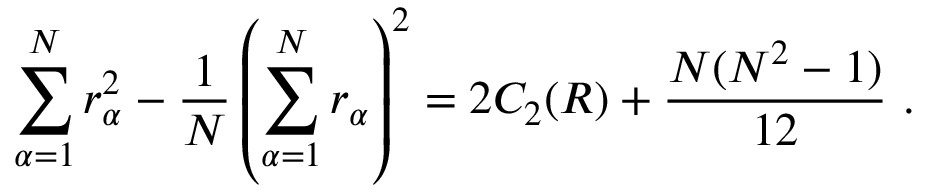Convert formula to latex. <formula><loc_0><loc_0><loc_500><loc_500>\sum _ { \alpha = 1 } ^ { N } r _ { \alpha } ^ { 2 } - \frac { 1 } { N } \left ( \sum _ { \alpha = 1 } ^ { N } r _ { \alpha } \right ) ^ { 2 } = 2 C _ { 2 } ( R ) + \frac { N ( N ^ { 2 } - 1 ) } { 1 2 } \ .</formula> 